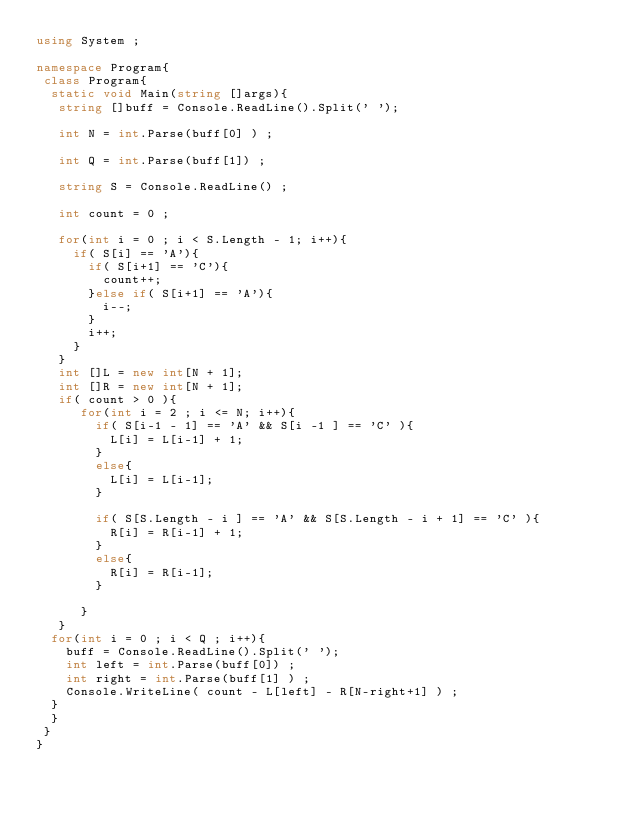Convert code to text. <code><loc_0><loc_0><loc_500><loc_500><_C#_>using System ; 

namespace Program{
 class Program{
  static void Main(string []args){
   string []buff = Console.ReadLine().Split(' ');
    
   int N = int.Parse(buff[0] ) ;
   
   int Q = int.Parse(buff[1]) ;
    
   string S = Console.ReadLine() ; 
    
   int count = 0 ;
    
   for(int i = 0 ; i < S.Length - 1; i++){
     if( S[i] == 'A'){
       if( S[i+1] == 'C'){
         count++; 
       }else if( S[i+1] == 'A'){
         i--;
       }
       i++;
     }
   }
   int []L = new int[N + 1];
   int []R = new int[N + 1]; 
   if( count > 0 ){
      for(int i = 2 ; i <= N; i++){
        if( S[i-1 - 1] == 'A' && S[i -1 ] == 'C' ){
          L[i] = L[i-1] + 1;
        }
        else{
          L[i] = L[i-1]; 
        }
        
        if( S[S.Length - i ] == 'A' && S[S.Length - i + 1] == 'C' ){
          R[i] = R[i-1] + 1;
        }
        else{
          R[i] = R[i-1]; 
        }
        
      }     
   }
  for(int i = 0 ; i < Q ; i++){
    buff = Console.ReadLine().Split(' ');
    int left = int.Parse(buff[0]) ;
    int right = int.Parse(buff[1] ) ; 
    Console.WriteLine( count - L[left] - R[N-right+1] ) ;
  }
  }
 }
}</code> 